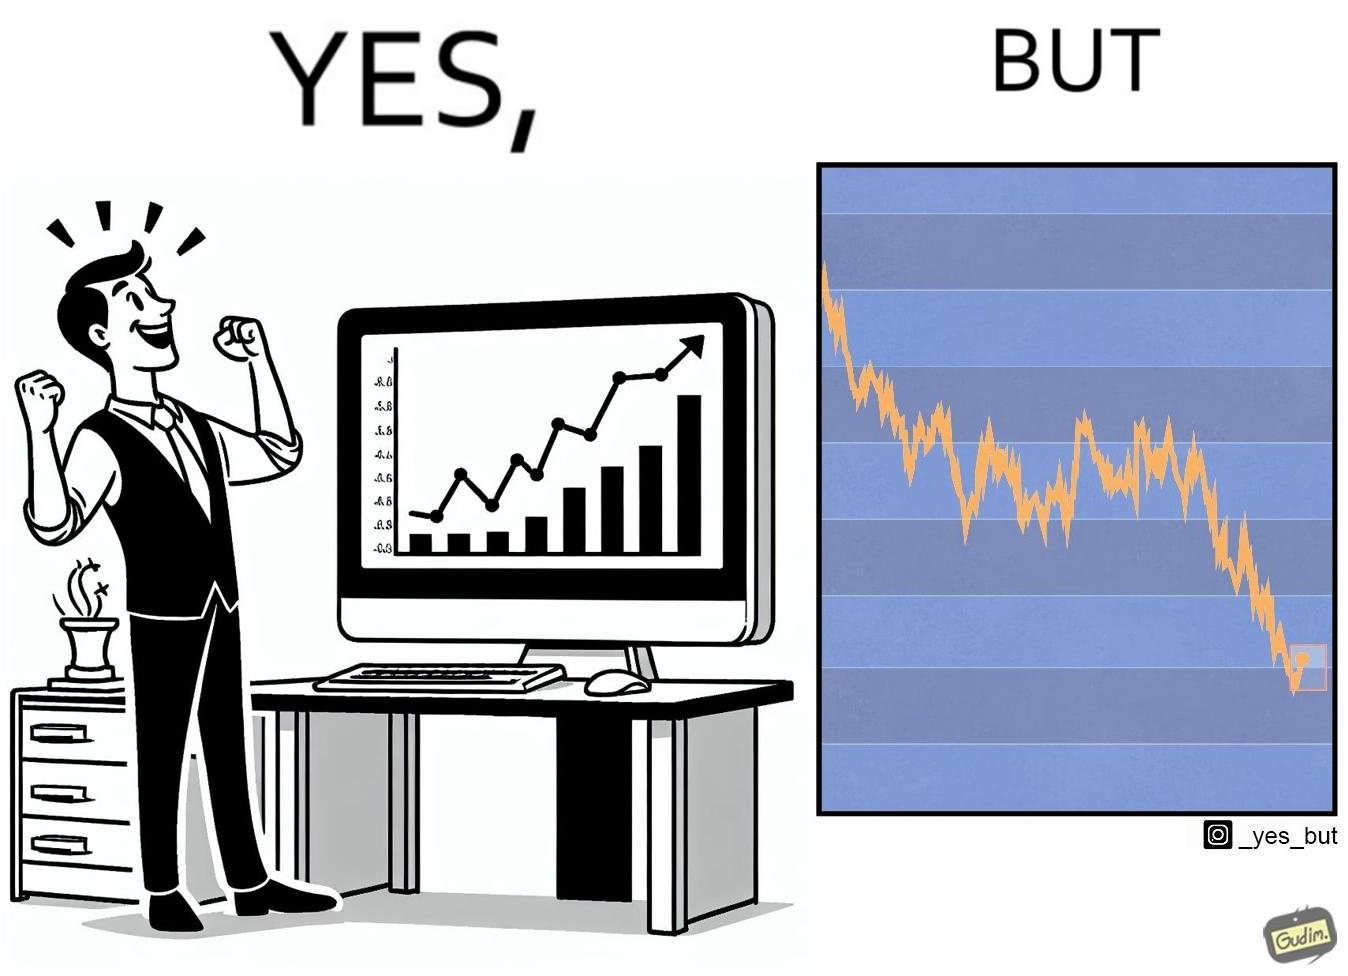Is there satirical content in this image? Yes, this image is satirical. 